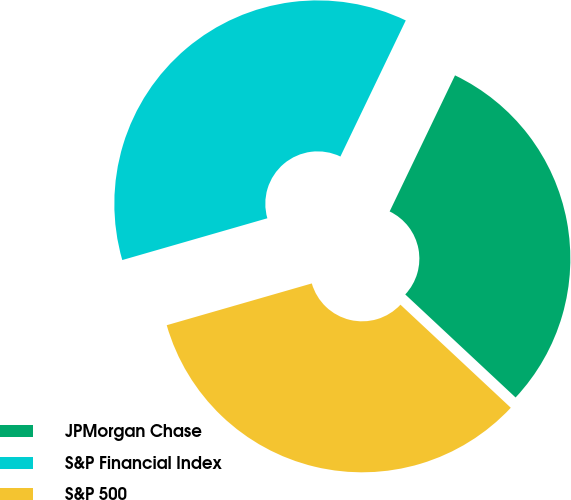Convert chart to OTSL. <chart><loc_0><loc_0><loc_500><loc_500><pie_chart><fcel>JPMorgan Chase<fcel>S&P Financial Index<fcel>S&P 500<nl><fcel>29.83%<fcel>36.59%<fcel>33.58%<nl></chart> 